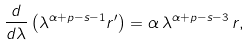<formula> <loc_0><loc_0><loc_500><loc_500>\frac { d } { d \lambda } \left ( \lambda ^ { \alpha + p - s - 1 } r ^ { \prime } \right ) = \alpha \, \lambda ^ { \alpha + p - s - 3 } \, r ,</formula> 